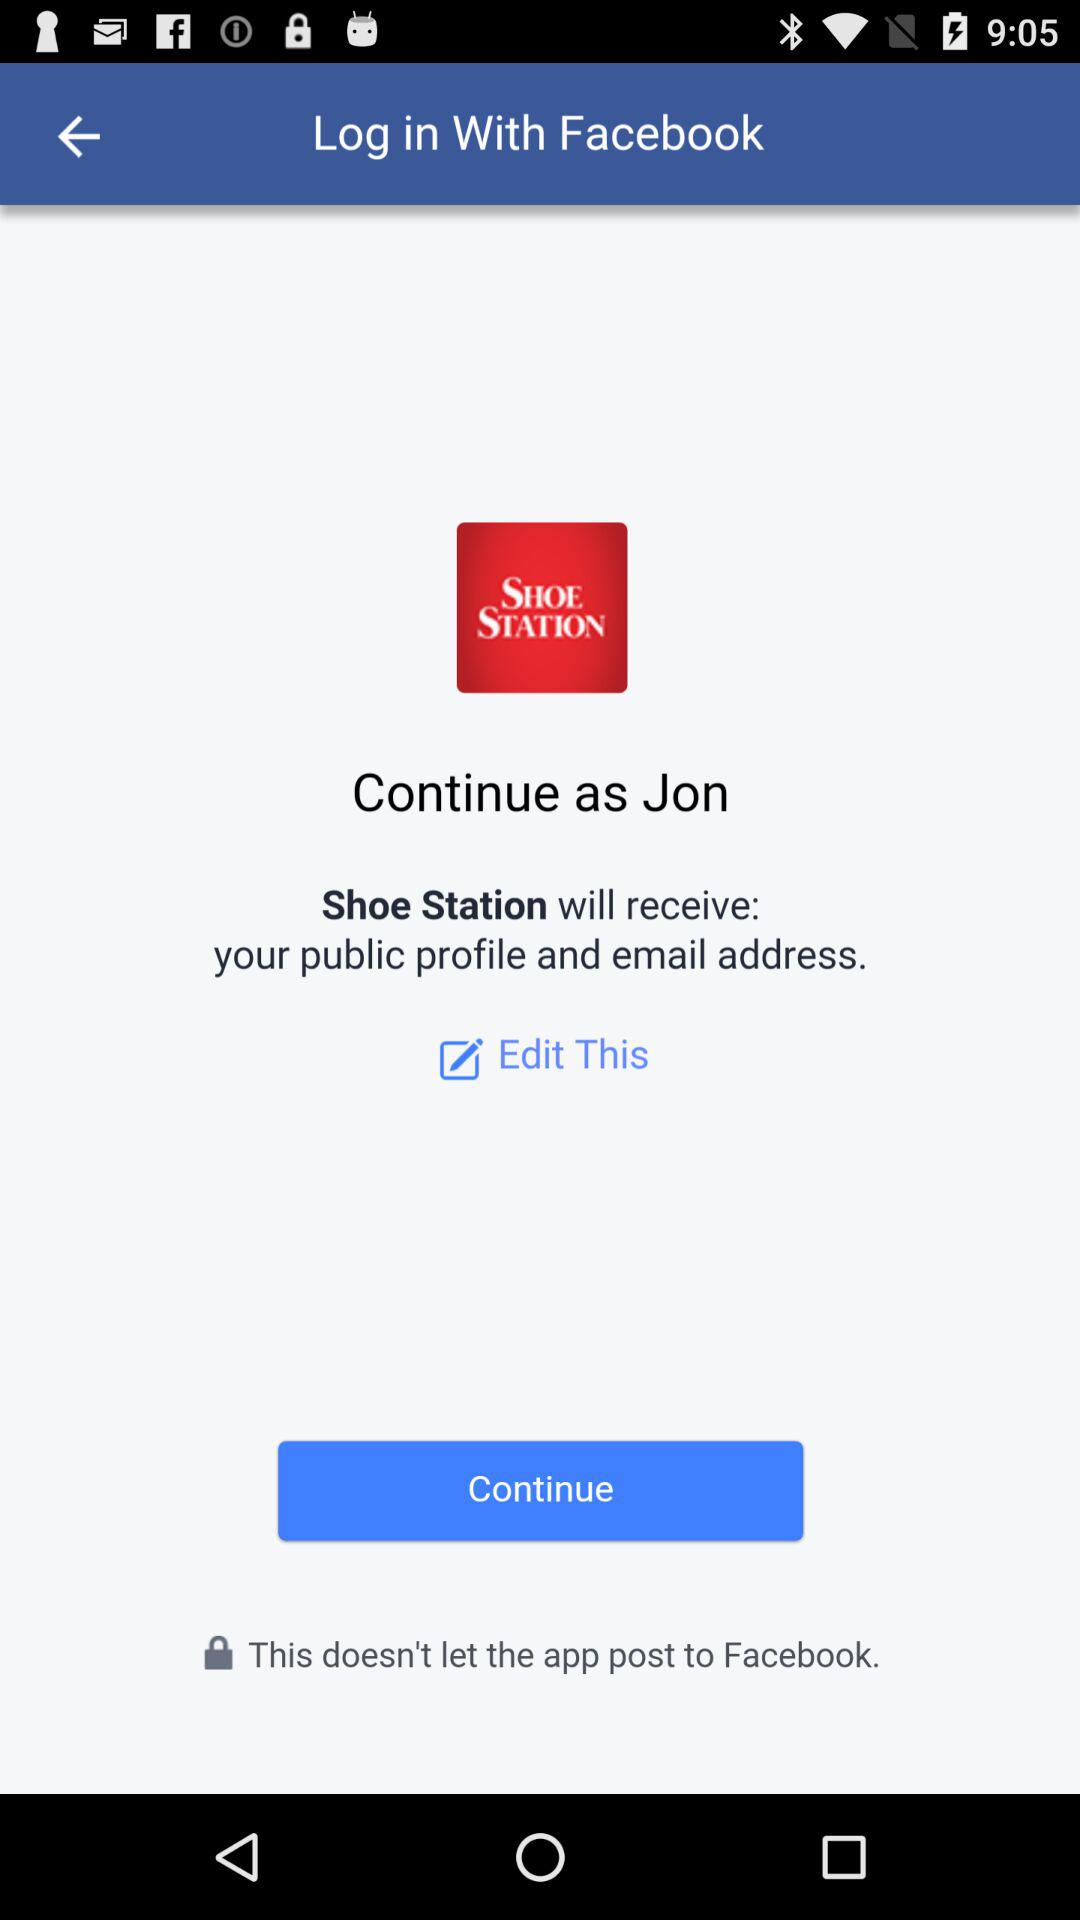What application is asking for permission? The application "Shoe Station" is asking for permission. 